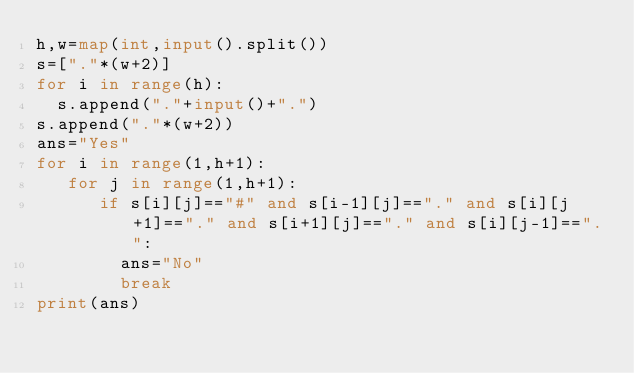<code> <loc_0><loc_0><loc_500><loc_500><_Python_>h,w=map(int,input().split())
s=["."*(w+2)]
for i in range(h):
  s.append("."+input()+".")
s.append("."*(w+2))
ans="Yes"
for i in range(1,h+1):
   for j in range(1,h+1):
      if s[i][j]=="#" and s[i-1][j]=="." and s[i][j+1]=="." and s[i+1][j]=="." and s[i][j-1]==".":
        ans="No"
        break
print(ans)</code> 